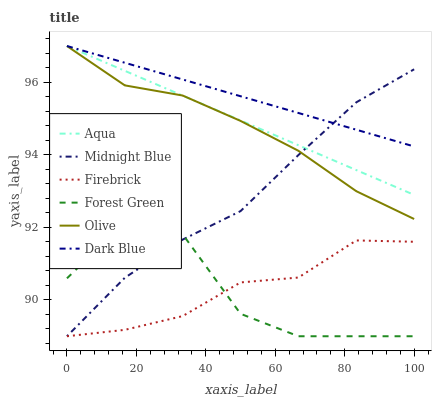Does Forest Green have the minimum area under the curve?
Answer yes or no. Yes. Does Dark Blue have the maximum area under the curve?
Answer yes or no. Yes. Does Firebrick have the minimum area under the curve?
Answer yes or no. No. Does Firebrick have the maximum area under the curve?
Answer yes or no. No. Is Dark Blue the smoothest?
Answer yes or no. Yes. Is Forest Green the roughest?
Answer yes or no. Yes. Is Firebrick the smoothest?
Answer yes or no. No. Is Firebrick the roughest?
Answer yes or no. No. Does Midnight Blue have the lowest value?
Answer yes or no. Yes. Does Aqua have the lowest value?
Answer yes or no. No. Does Olive have the highest value?
Answer yes or no. Yes. Does Firebrick have the highest value?
Answer yes or no. No. Is Forest Green less than Dark Blue?
Answer yes or no. Yes. Is Olive greater than Firebrick?
Answer yes or no. Yes. Does Dark Blue intersect Midnight Blue?
Answer yes or no. Yes. Is Dark Blue less than Midnight Blue?
Answer yes or no. No. Is Dark Blue greater than Midnight Blue?
Answer yes or no. No. Does Forest Green intersect Dark Blue?
Answer yes or no. No. 